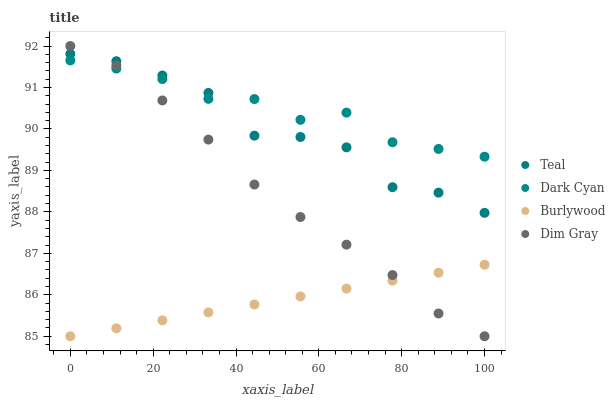Does Burlywood have the minimum area under the curve?
Answer yes or no. Yes. Does Dark Cyan have the maximum area under the curve?
Answer yes or no. Yes. Does Dim Gray have the minimum area under the curve?
Answer yes or no. No. Does Dim Gray have the maximum area under the curve?
Answer yes or no. No. Is Burlywood the smoothest?
Answer yes or no. Yes. Is Teal the roughest?
Answer yes or no. Yes. Is Dim Gray the smoothest?
Answer yes or no. No. Is Dim Gray the roughest?
Answer yes or no. No. Does Burlywood have the lowest value?
Answer yes or no. Yes. Does Teal have the lowest value?
Answer yes or no. No. Does Dim Gray have the highest value?
Answer yes or no. Yes. Does Burlywood have the highest value?
Answer yes or no. No. Is Burlywood less than Teal?
Answer yes or no. Yes. Is Dark Cyan greater than Burlywood?
Answer yes or no. Yes. Does Teal intersect Dim Gray?
Answer yes or no. Yes. Is Teal less than Dim Gray?
Answer yes or no. No. Is Teal greater than Dim Gray?
Answer yes or no. No. Does Burlywood intersect Teal?
Answer yes or no. No. 